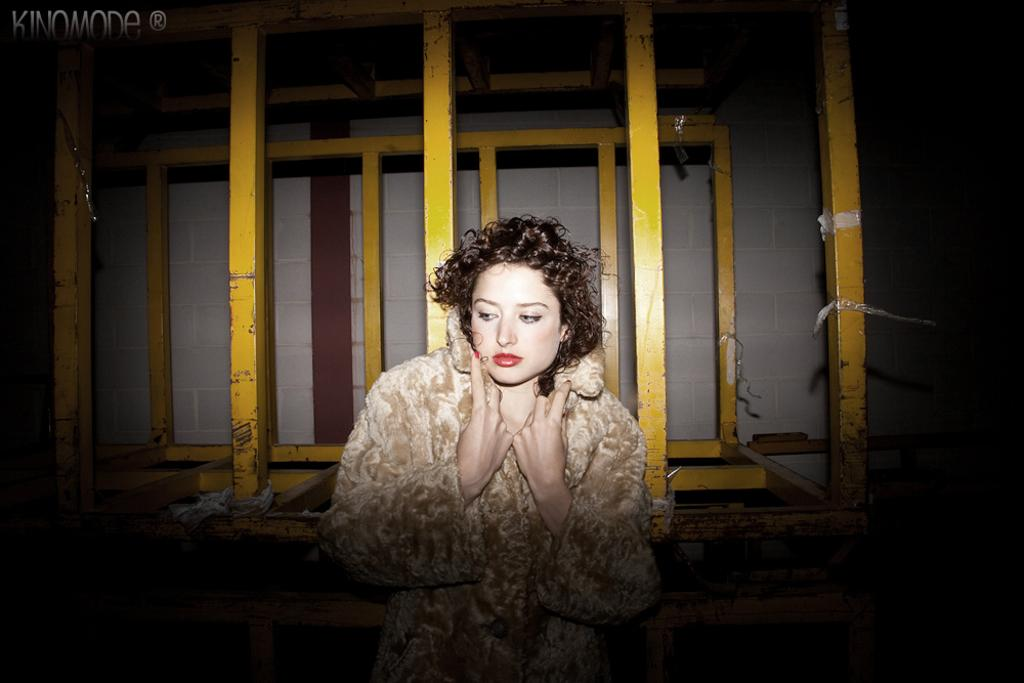What is the woman holding in the image? There is a woman in the image, and she is holding a book. What else can be seen in the image besides the woman and the book? There are poles visible in the image, and there is a wall in the image. What type of jeans is the jellyfish wearing in the image? There is no jellyfish or jeans present in the image. 